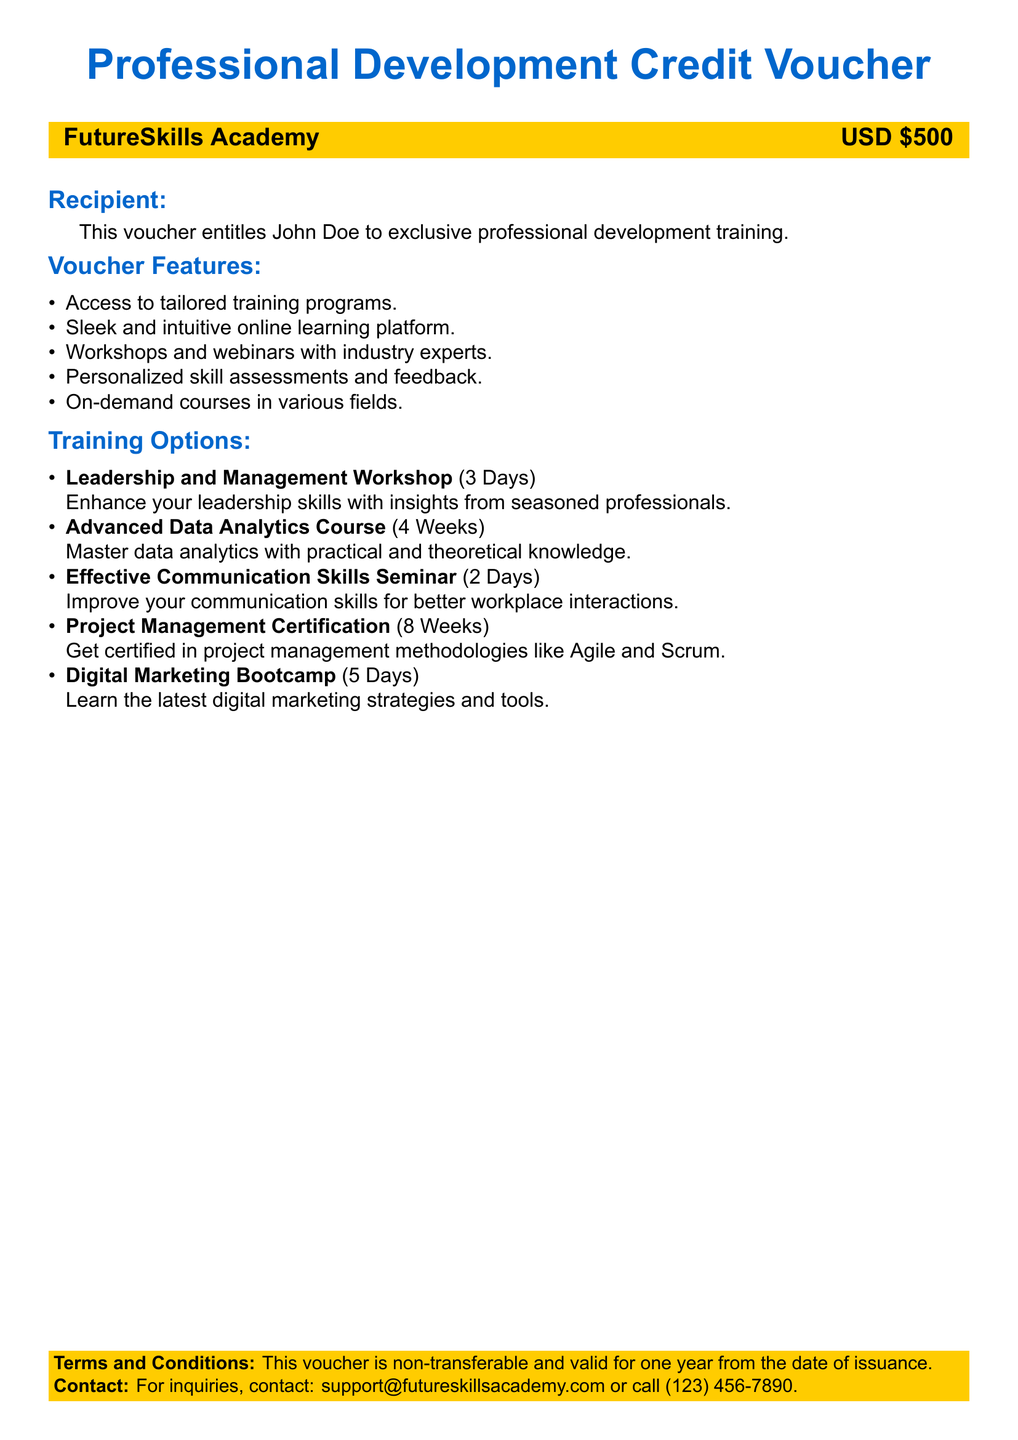what is the value of the voucher? The value is explicitly stated in the document as USD 500.
Answer: USD 500 who is the recipient of the voucher? The recipient's name is mentioned in the document for exclusive training entitlement.
Answer: John Doe how many training programs are listed? The document lists five different training programs under the training options section.
Answer: 5 what is the duration of the Advanced Data Analytics Course? The duration is explicitly mentioned in the training options section of the document.
Answer: 4 Weeks is the voucher transferable? The terms and conditions clearly state the voucher is non-transferable.
Answer: Non-transferable what type of training does the voucher provide access to? The document specifies that it provides access to tailored training programs.
Answer: Tailored training programs how long is the Leadership and Management Workshop? The duration of the workshop is specified in days in the training options section.
Answer: 3 Days what is the contact email for inquiries? The document provides an email address for support inquiries.
Answer: support@futureskillsacademy.com 